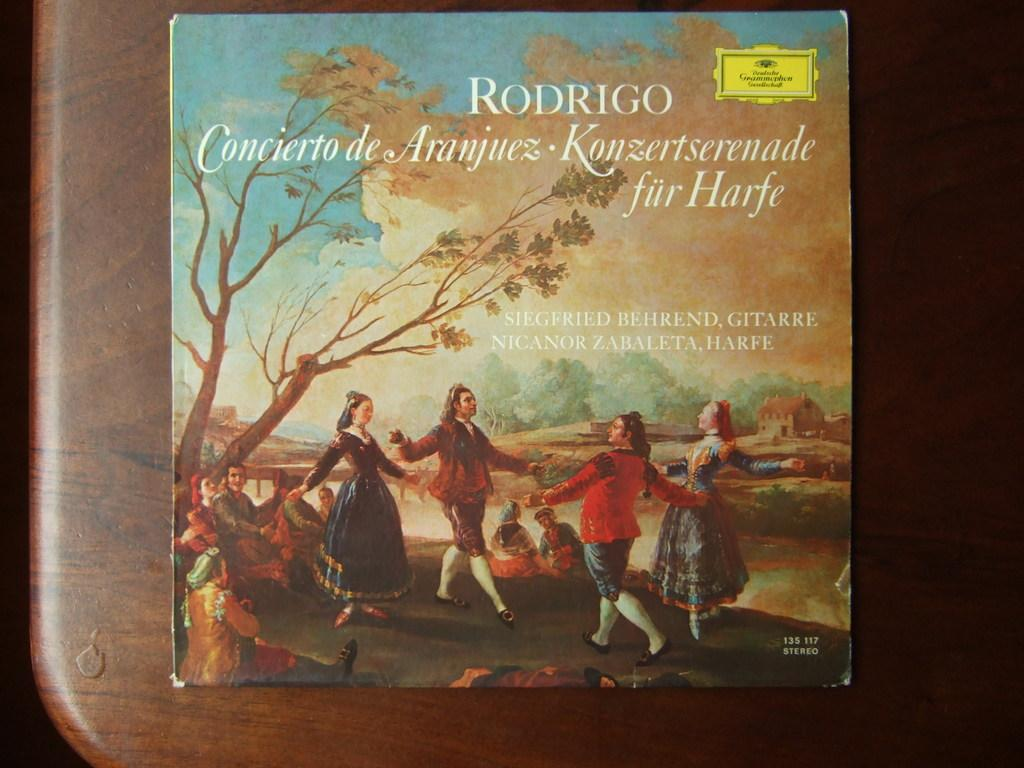<image>
Write a terse but informative summary of the picture. A Rodrigo album featuring old art is on a wooden table. 